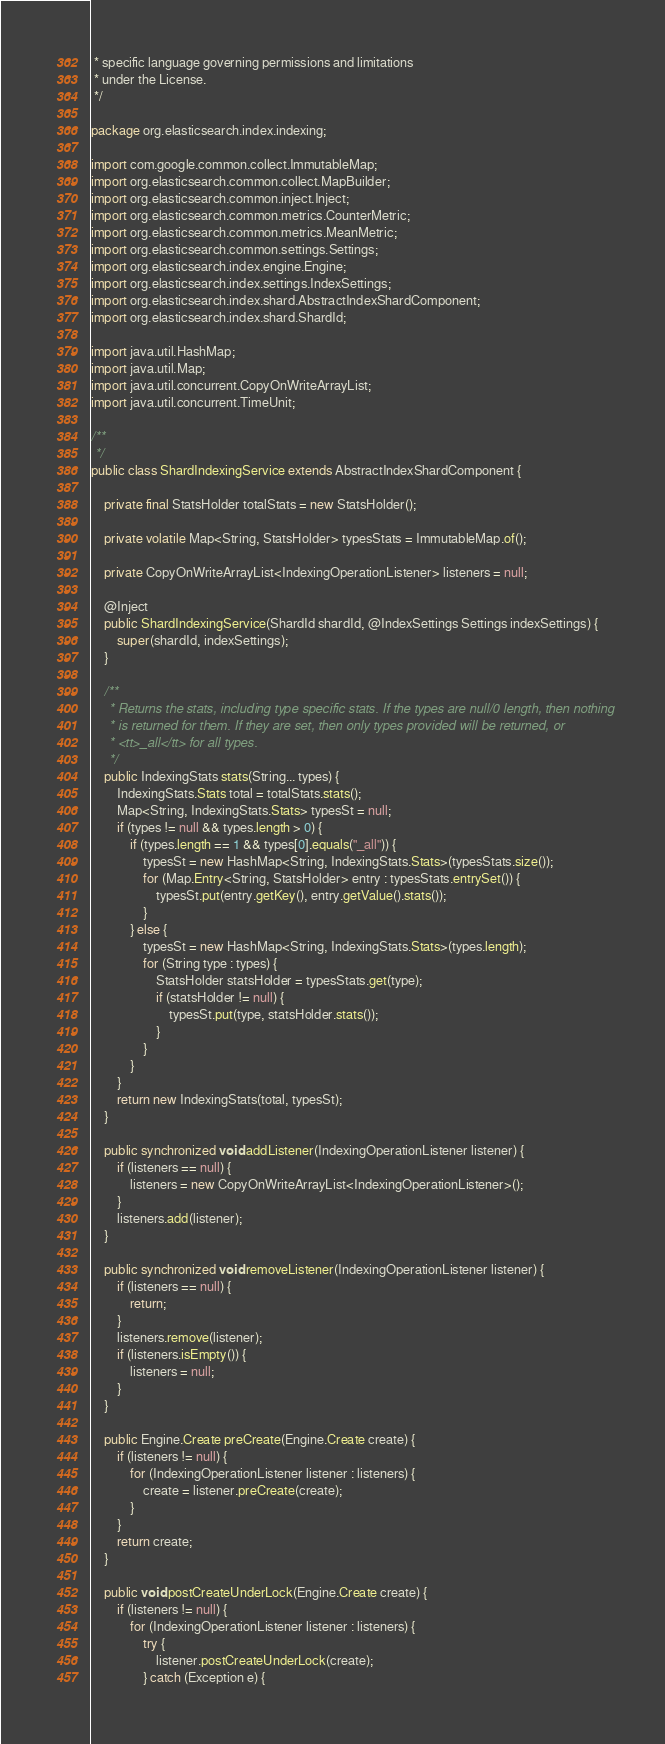Convert code to text. <code><loc_0><loc_0><loc_500><loc_500><_Java_> * specific language governing permissions and limitations
 * under the License.
 */

package org.elasticsearch.index.indexing;

import com.google.common.collect.ImmutableMap;
import org.elasticsearch.common.collect.MapBuilder;
import org.elasticsearch.common.inject.Inject;
import org.elasticsearch.common.metrics.CounterMetric;
import org.elasticsearch.common.metrics.MeanMetric;
import org.elasticsearch.common.settings.Settings;
import org.elasticsearch.index.engine.Engine;
import org.elasticsearch.index.settings.IndexSettings;
import org.elasticsearch.index.shard.AbstractIndexShardComponent;
import org.elasticsearch.index.shard.ShardId;

import java.util.HashMap;
import java.util.Map;
import java.util.concurrent.CopyOnWriteArrayList;
import java.util.concurrent.TimeUnit;

/**
 */
public class ShardIndexingService extends AbstractIndexShardComponent {

    private final StatsHolder totalStats = new StatsHolder();

    private volatile Map<String, StatsHolder> typesStats = ImmutableMap.of();

    private CopyOnWriteArrayList<IndexingOperationListener> listeners = null;

    @Inject
    public ShardIndexingService(ShardId shardId, @IndexSettings Settings indexSettings) {
        super(shardId, indexSettings);
    }

    /**
     * Returns the stats, including type specific stats. If the types are null/0 length, then nothing
     * is returned for them. If they are set, then only types provided will be returned, or
     * <tt>_all</tt> for all types.
     */
    public IndexingStats stats(String... types) {
        IndexingStats.Stats total = totalStats.stats();
        Map<String, IndexingStats.Stats> typesSt = null;
        if (types != null && types.length > 0) {
            if (types.length == 1 && types[0].equals("_all")) {
                typesSt = new HashMap<String, IndexingStats.Stats>(typesStats.size());
                for (Map.Entry<String, StatsHolder> entry : typesStats.entrySet()) {
                    typesSt.put(entry.getKey(), entry.getValue().stats());
                }
            } else {
                typesSt = new HashMap<String, IndexingStats.Stats>(types.length);
                for (String type : types) {
                    StatsHolder statsHolder = typesStats.get(type);
                    if (statsHolder != null) {
                        typesSt.put(type, statsHolder.stats());
                    }
                }
            }
        }
        return new IndexingStats(total, typesSt);
    }

    public synchronized void addListener(IndexingOperationListener listener) {
        if (listeners == null) {
            listeners = new CopyOnWriteArrayList<IndexingOperationListener>();
        }
        listeners.add(listener);
    }

    public synchronized void removeListener(IndexingOperationListener listener) {
        if (listeners == null) {
            return;
        }
        listeners.remove(listener);
        if (listeners.isEmpty()) {
            listeners = null;
        }
    }

    public Engine.Create preCreate(Engine.Create create) {
        if (listeners != null) {
            for (IndexingOperationListener listener : listeners) {
                create = listener.preCreate(create);
            }
        }
        return create;
    }

    public void postCreateUnderLock(Engine.Create create) {
        if (listeners != null) {
            for (IndexingOperationListener listener : listeners) {
                try {
                    listener.postCreateUnderLock(create);
                } catch (Exception e) {</code> 